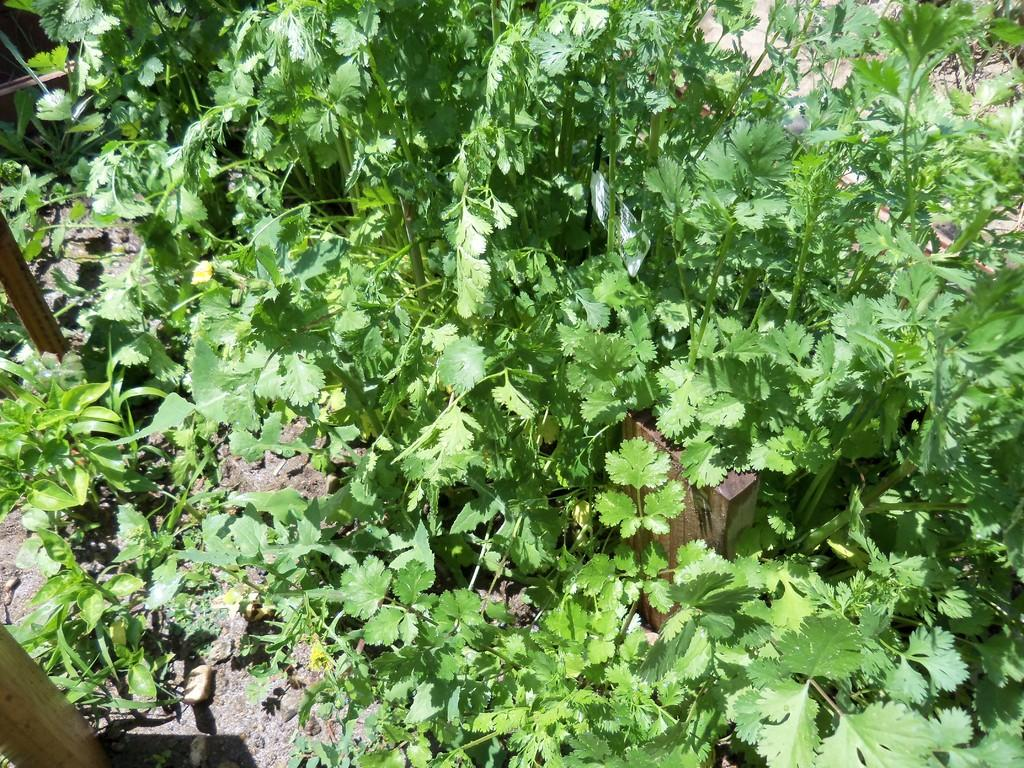What type of vegetation can be seen on the ground in the image? There are plants on the ground in the image. What are the plants doing in the image? The plants have flowers. What is located in the center of the image? There is a wall in the center of the image. What can be found on the left side of the image? There are sticks on the ground to the left side of the image. How many requests are being made by the plants in the image? There are no requests being made by the plants in the image, as plants do not have the ability to make requests. 